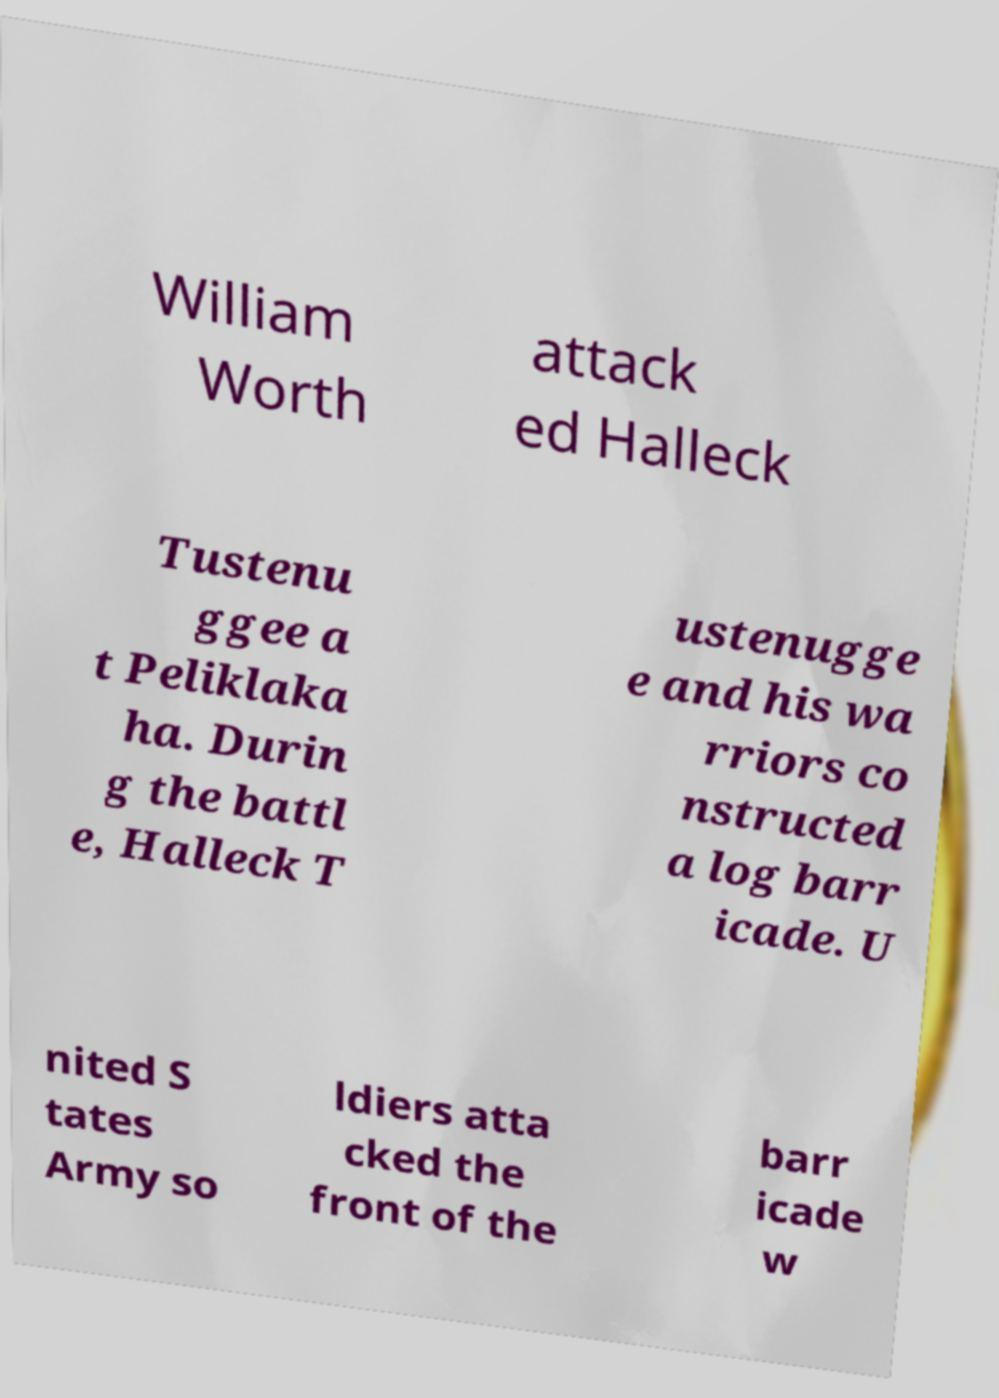I need the written content from this picture converted into text. Can you do that? William Worth attack ed Halleck Tustenu ggee a t Peliklaka ha. Durin g the battl e, Halleck T ustenugge e and his wa rriors co nstructed a log barr icade. U nited S tates Army so ldiers atta cked the front of the barr icade w 